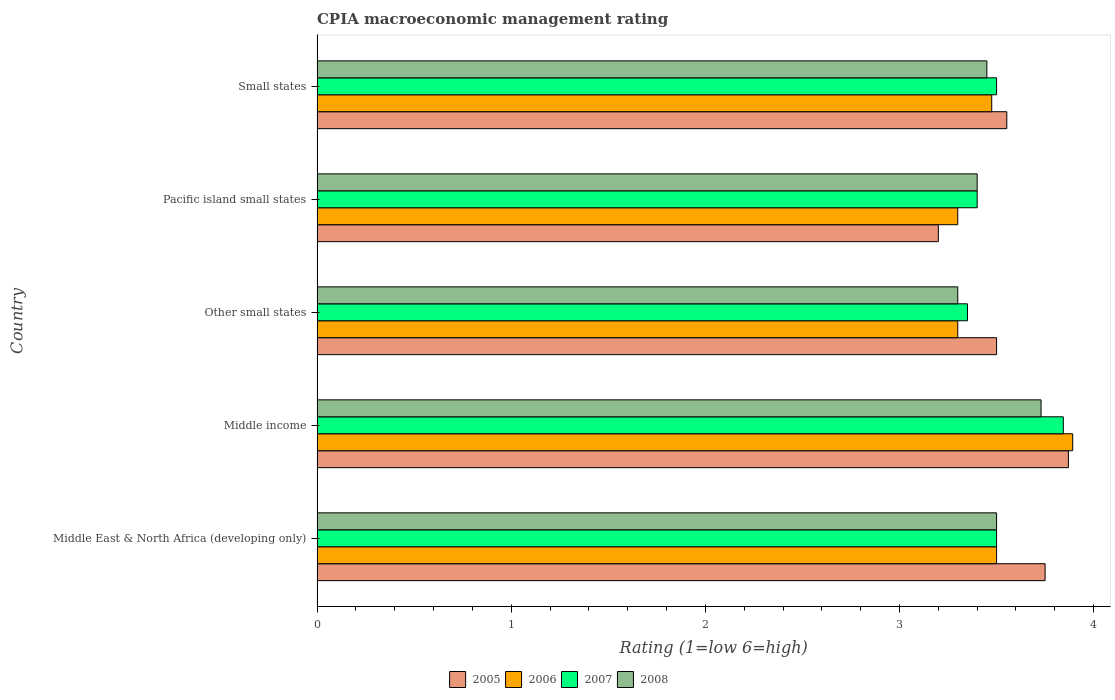How many different coloured bars are there?
Your response must be concise. 4. Are the number of bars on each tick of the Y-axis equal?
Your response must be concise. Yes. How many bars are there on the 5th tick from the top?
Your answer should be very brief. 4. How many bars are there on the 4th tick from the bottom?
Offer a terse response. 4. What is the label of the 5th group of bars from the top?
Provide a succinct answer. Middle East & North Africa (developing only). In how many cases, is the number of bars for a given country not equal to the number of legend labels?
Offer a very short reply. 0. Across all countries, what is the maximum CPIA rating in 2006?
Give a very brief answer. 3.89. In which country was the CPIA rating in 2006 minimum?
Ensure brevity in your answer.  Other small states. What is the total CPIA rating in 2007 in the graph?
Provide a short and direct response. 17.59. What is the difference between the CPIA rating in 2008 in Pacific island small states and that in Small states?
Make the answer very short. -0.05. What is the difference between the CPIA rating in 2006 in Pacific island small states and the CPIA rating in 2008 in Small states?
Your response must be concise. -0.15. What is the average CPIA rating in 2007 per country?
Provide a short and direct response. 3.52. What is the difference between the CPIA rating in 2008 and CPIA rating in 2005 in Middle income?
Give a very brief answer. -0.14. In how many countries, is the CPIA rating in 2005 greater than 0.2 ?
Offer a very short reply. 5. What is the ratio of the CPIA rating in 2007 in Other small states to that in Pacific island small states?
Your answer should be compact. 0.99. What is the difference between the highest and the second highest CPIA rating in 2006?
Offer a very short reply. 0.39. What is the difference between the highest and the lowest CPIA rating in 2008?
Your answer should be compact. 0.43. Is the sum of the CPIA rating in 2007 in Middle East & North Africa (developing only) and Pacific island small states greater than the maximum CPIA rating in 2006 across all countries?
Make the answer very short. Yes. How many bars are there?
Your response must be concise. 20. Are all the bars in the graph horizontal?
Keep it short and to the point. Yes. Are the values on the major ticks of X-axis written in scientific E-notation?
Your response must be concise. No. Does the graph contain any zero values?
Ensure brevity in your answer.  No. How many legend labels are there?
Your answer should be very brief. 4. How are the legend labels stacked?
Ensure brevity in your answer.  Horizontal. What is the title of the graph?
Offer a terse response. CPIA macroeconomic management rating. What is the label or title of the X-axis?
Your answer should be compact. Rating (1=low 6=high). What is the label or title of the Y-axis?
Give a very brief answer. Country. What is the Rating (1=low 6=high) in 2005 in Middle East & North Africa (developing only)?
Your response must be concise. 3.75. What is the Rating (1=low 6=high) in 2006 in Middle East & North Africa (developing only)?
Make the answer very short. 3.5. What is the Rating (1=low 6=high) of 2007 in Middle East & North Africa (developing only)?
Your answer should be compact. 3.5. What is the Rating (1=low 6=high) of 2005 in Middle income?
Ensure brevity in your answer.  3.87. What is the Rating (1=low 6=high) of 2006 in Middle income?
Your answer should be compact. 3.89. What is the Rating (1=low 6=high) in 2007 in Middle income?
Offer a terse response. 3.84. What is the Rating (1=low 6=high) in 2008 in Middle income?
Make the answer very short. 3.73. What is the Rating (1=low 6=high) of 2007 in Other small states?
Ensure brevity in your answer.  3.35. What is the Rating (1=low 6=high) of 2008 in Other small states?
Your answer should be very brief. 3.3. What is the Rating (1=low 6=high) of 2005 in Pacific island small states?
Offer a very short reply. 3.2. What is the Rating (1=low 6=high) of 2006 in Pacific island small states?
Make the answer very short. 3.3. What is the Rating (1=low 6=high) of 2007 in Pacific island small states?
Keep it short and to the point. 3.4. What is the Rating (1=low 6=high) of 2008 in Pacific island small states?
Your answer should be very brief. 3.4. What is the Rating (1=low 6=high) in 2005 in Small states?
Make the answer very short. 3.55. What is the Rating (1=low 6=high) of 2006 in Small states?
Offer a very short reply. 3.48. What is the Rating (1=low 6=high) of 2007 in Small states?
Provide a succinct answer. 3.5. What is the Rating (1=low 6=high) in 2008 in Small states?
Keep it short and to the point. 3.45. Across all countries, what is the maximum Rating (1=low 6=high) of 2005?
Provide a short and direct response. 3.87. Across all countries, what is the maximum Rating (1=low 6=high) in 2006?
Ensure brevity in your answer.  3.89. Across all countries, what is the maximum Rating (1=low 6=high) of 2007?
Ensure brevity in your answer.  3.84. Across all countries, what is the maximum Rating (1=low 6=high) in 2008?
Offer a terse response. 3.73. Across all countries, what is the minimum Rating (1=low 6=high) in 2006?
Your answer should be compact. 3.3. Across all countries, what is the minimum Rating (1=low 6=high) in 2007?
Offer a very short reply. 3.35. What is the total Rating (1=low 6=high) in 2005 in the graph?
Ensure brevity in your answer.  17.87. What is the total Rating (1=low 6=high) in 2006 in the graph?
Provide a succinct answer. 17.47. What is the total Rating (1=low 6=high) in 2007 in the graph?
Provide a short and direct response. 17.59. What is the total Rating (1=low 6=high) of 2008 in the graph?
Give a very brief answer. 17.38. What is the difference between the Rating (1=low 6=high) of 2005 in Middle East & North Africa (developing only) and that in Middle income?
Your response must be concise. -0.12. What is the difference between the Rating (1=low 6=high) in 2006 in Middle East & North Africa (developing only) and that in Middle income?
Ensure brevity in your answer.  -0.39. What is the difference between the Rating (1=low 6=high) in 2007 in Middle East & North Africa (developing only) and that in Middle income?
Give a very brief answer. -0.34. What is the difference between the Rating (1=low 6=high) of 2008 in Middle East & North Africa (developing only) and that in Middle income?
Make the answer very short. -0.23. What is the difference between the Rating (1=low 6=high) of 2005 in Middle East & North Africa (developing only) and that in Other small states?
Your answer should be very brief. 0.25. What is the difference between the Rating (1=low 6=high) of 2006 in Middle East & North Africa (developing only) and that in Other small states?
Offer a very short reply. 0.2. What is the difference between the Rating (1=low 6=high) of 2007 in Middle East & North Africa (developing only) and that in Other small states?
Your response must be concise. 0.15. What is the difference between the Rating (1=low 6=high) of 2008 in Middle East & North Africa (developing only) and that in Other small states?
Your response must be concise. 0.2. What is the difference between the Rating (1=low 6=high) in 2005 in Middle East & North Africa (developing only) and that in Pacific island small states?
Offer a very short reply. 0.55. What is the difference between the Rating (1=low 6=high) of 2006 in Middle East & North Africa (developing only) and that in Pacific island small states?
Make the answer very short. 0.2. What is the difference between the Rating (1=low 6=high) in 2005 in Middle East & North Africa (developing only) and that in Small states?
Offer a terse response. 0.2. What is the difference between the Rating (1=low 6=high) of 2006 in Middle East & North Africa (developing only) and that in Small states?
Your answer should be very brief. 0.03. What is the difference between the Rating (1=low 6=high) in 2007 in Middle East & North Africa (developing only) and that in Small states?
Ensure brevity in your answer.  0. What is the difference between the Rating (1=low 6=high) in 2008 in Middle East & North Africa (developing only) and that in Small states?
Offer a very short reply. 0.05. What is the difference between the Rating (1=low 6=high) in 2005 in Middle income and that in Other small states?
Make the answer very short. 0.37. What is the difference between the Rating (1=low 6=high) of 2006 in Middle income and that in Other small states?
Keep it short and to the point. 0.59. What is the difference between the Rating (1=low 6=high) in 2007 in Middle income and that in Other small states?
Make the answer very short. 0.49. What is the difference between the Rating (1=low 6=high) of 2008 in Middle income and that in Other small states?
Ensure brevity in your answer.  0.43. What is the difference between the Rating (1=low 6=high) of 2005 in Middle income and that in Pacific island small states?
Your answer should be compact. 0.67. What is the difference between the Rating (1=low 6=high) in 2006 in Middle income and that in Pacific island small states?
Your answer should be compact. 0.59. What is the difference between the Rating (1=low 6=high) in 2007 in Middle income and that in Pacific island small states?
Your answer should be compact. 0.44. What is the difference between the Rating (1=low 6=high) of 2008 in Middle income and that in Pacific island small states?
Provide a succinct answer. 0.33. What is the difference between the Rating (1=low 6=high) of 2005 in Middle income and that in Small states?
Your answer should be very brief. 0.32. What is the difference between the Rating (1=low 6=high) of 2006 in Middle income and that in Small states?
Provide a succinct answer. 0.42. What is the difference between the Rating (1=low 6=high) in 2007 in Middle income and that in Small states?
Your answer should be compact. 0.34. What is the difference between the Rating (1=low 6=high) in 2008 in Middle income and that in Small states?
Keep it short and to the point. 0.28. What is the difference between the Rating (1=low 6=high) in 2005 in Other small states and that in Pacific island small states?
Keep it short and to the point. 0.3. What is the difference between the Rating (1=low 6=high) of 2006 in Other small states and that in Pacific island small states?
Ensure brevity in your answer.  0. What is the difference between the Rating (1=low 6=high) of 2008 in Other small states and that in Pacific island small states?
Ensure brevity in your answer.  -0.1. What is the difference between the Rating (1=low 6=high) of 2005 in Other small states and that in Small states?
Your answer should be very brief. -0.05. What is the difference between the Rating (1=low 6=high) in 2006 in Other small states and that in Small states?
Give a very brief answer. -0.17. What is the difference between the Rating (1=low 6=high) in 2007 in Other small states and that in Small states?
Ensure brevity in your answer.  -0.15. What is the difference between the Rating (1=low 6=high) in 2005 in Pacific island small states and that in Small states?
Offer a very short reply. -0.35. What is the difference between the Rating (1=low 6=high) in 2006 in Pacific island small states and that in Small states?
Your response must be concise. -0.17. What is the difference between the Rating (1=low 6=high) in 2008 in Pacific island small states and that in Small states?
Keep it short and to the point. -0.05. What is the difference between the Rating (1=low 6=high) in 2005 in Middle East & North Africa (developing only) and the Rating (1=low 6=high) in 2006 in Middle income?
Your answer should be very brief. -0.14. What is the difference between the Rating (1=low 6=high) of 2005 in Middle East & North Africa (developing only) and the Rating (1=low 6=high) of 2007 in Middle income?
Your answer should be compact. -0.09. What is the difference between the Rating (1=low 6=high) of 2005 in Middle East & North Africa (developing only) and the Rating (1=low 6=high) of 2008 in Middle income?
Your response must be concise. 0.02. What is the difference between the Rating (1=low 6=high) in 2006 in Middle East & North Africa (developing only) and the Rating (1=low 6=high) in 2007 in Middle income?
Keep it short and to the point. -0.34. What is the difference between the Rating (1=low 6=high) in 2006 in Middle East & North Africa (developing only) and the Rating (1=low 6=high) in 2008 in Middle income?
Provide a short and direct response. -0.23. What is the difference between the Rating (1=low 6=high) in 2007 in Middle East & North Africa (developing only) and the Rating (1=low 6=high) in 2008 in Middle income?
Provide a short and direct response. -0.23. What is the difference between the Rating (1=low 6=high) of 2005 in Middle East & North Africa (developing only) and the Rating (1=low 6=high) of 2006 in Other small states?
Offer a terse response. 0.45. What is the difference between the Rating (1=low 6=high) in 2005 in Middle East & North Africa (developing only) and the Rating (1=low 6=high) in 2007 in Other small states?
Make the answer very short. 0.4. What is the difference between the Rating (1=low 6=high) in 2005 in Middle East & North Africa (developing only) and the Rating (1=low 6=high) in 2008 in Other small states?
Your answer should be compact. 0.45. What is the difference between the Rating (1=low 6=high) of 2006 in Middle East & North Africa (developing only) and the Rating (1=low 6=high) of 2007 in Other small states?
Ensure brevity in your answer.  0.15. What is the difference between the Rating (1=low 6=high) of 2006 in Middle East & North Africa (developing only) and the Rating (1=low 6=high) of 2008 in Other small states?
Keep it short and to the point. 0.2. What is the difference between the Rating (1=low 6=high) of 2005 in Middle East & North Africa (developing only) and the Rating (1=low 6=high) of 2006 in Pacific island small states?
Make the answer very short. 0.45. What is the difference between the Rating (1=low 6=high) in 2005 in Middle East & North Africa (developing only) and the Rating (1=low 6=high) in 2007 in Pacific island small states?
Offer a very short reply. 0.35. What is the difference between the Rating (1=low 6=high) in 2005 in Middle East & North Africa (developing only) and the Rating (1=low 6=high) in 2006 in Small states?
Ensure brevity in your answer.  0.28. What is the difference between the Rating (1=low 6=high) of 2005 in Middle East & North Africa (developing only) and the Rating (1=low 6=high) of 2008 in Small states?
Your answer should be very brief. 0.3. What is the difference between the Rating (1=low 6=high) of 2006 in Middle East & North Africa (developing only) and the Rating (1=low 6=high) of 2007 in Small states?
Your response must be concise. 0. What is the difference between the Rating (1=low 6=high) of 2007 in Middle East & North Africa (developing only) and the Rating (1=low 6=high) of 2008 in Small states?
Offer a very short reply. 0.05. What is the difference between the Rating (1=low 6=high) in 2005 in Middle income and the Rating (1=low 6=high) in 2006 in Other small states?
Offer a terse response. 0.57. What is the difference between the Rating (1=low 6=high) of 2005 in Middle income and the Rating (1=low 6=high) of 2007 in Other small states?
Make the answer very short. 0.52. What is the difference between the Rating (1=low 6=high) in 2005 in Middle income and the Rating (1=low 6=high) in 2008 in Other small states?
Provide a succinct answer. 0.57. What is the difference between the Rating (1=low 6=high) in 2006 in Middle income and the Rating (1=low 6=high) in 2007 in Other small states?
Provide a succinct answer. 0.54. What is the difference between the Rating (1=low 6=high) in 2006 in Middle income and the Rating (1=low 6=high) in 2008 in Other small states?
Your answer should be compact. 0.59. What is the difference between the Rating (1=low 6=high) of 2007 in Middle income and the Rating (1=low 6=high) of 2008 in Other small states?
Keep it short and to the point. 0.54. What is the difference between the Rating (1=low 6=high) in 2005 in Middle income and the Rating (1=low 6=high) in 2006 in Pacific island small states?
Offer a very short reply. 0.57. What is the difference between the Rating (1=low 6=high) of 2005 in Middle income and the Rating (1=low 6=high) of 2007 in Pacific island small states?
Your answer should be very brief. 0.47. What is the difference between the Rating (1=low 6=high) of 2005 in Middle income and the Rating (1=low 6=high) of 2008 in Pacific island small states?
Make the answer very short. 0.47. What is the difference between the Rating (1=low 6=high) in 2006 in Middle income and the Rating (1=low 6=high) in 2007 in Pacific island small states?
Make the answer very short. 0.49. What is the difference between the Rating (1=low 6=high) of 2006 in Middle income and the Rating (1=low 6=high) of 2008 in Pacific island small states?
Ensure brevity in your answer.  0.49. What is the difference between the Rating (1=low 6=high) in 2007 in Middle income and the Rating (1=low 6=high) in 2008 in Pacific island small states?
Provide a short and direct response. 0.44. What is the difference between the Rating (1=low 6=high) of 2005 in Middle income and the Rating (1=low 6=high) of 2006 in Small states?
Make the answer very short. 0.4. What is the difference between the Rating (1=low 6=high) of 2005 in Middle income and the Rating (1=low 6=high) of 2007 in Small states?
Your answer should be compact. 0.37. What is the difference between the Rating (1=low 6=high) of 2005 in Middle income and the Rating (1=low 6=high) of 2008 in Small states?
Your response must be concise. 0.42. What is the difference between the Rating (1=low 6=high) in 2006 in Middle income and the Rating (1=low 6=high) in 2007 in Small states?
Make the answer very short. 0.39. What is the difference between the Rating (1=low 6=high) of 2006 in Middle income and the Rating (1=low 6=high) of 2008 in Small states?
Ensure brevity in your answer.  0.44. What is the difference between the Rating (1=low 6=high) of 2007 in Middle income and the Rating (1=low 6=high) of 2008 in Small states?
Offer a very short reply. 0.39. What is the difference between the Rating (1=low 6=high) of 2005 in Other small states and the Rating (1=low 6=high) of 2008 in Pacific island small states?
Offer a very short reply. 0.1. What is the difference between the Rating (1=low 6=high) in 2006 in Other small states and the Rating (1=low 6=high) in 2007 in Pacific island small states?
Offer a terse response. -0.1. What is the difference between the Rating (1=low 6=high) of 2005 in Other small states and the Rating (1=low 6=high) of 2006 in Small states?
Your answer should be very brief. 0.03. What is the difference between the Rating (1=low 6=high) of 2006 in Other small states and the Rating (1=low 6=high) of 2007 in Small states?
Your answer should be very brief. -0.2. What is the difference between the Rating (1=low 6=high) of 2006 in Other small states and the Rating (1=low 6=high) of 2008 in Small states?
Ensure brevity in your answer.  -0.15. What is the difference between the Rating (1=low 6=high) of 2005 in Pacific island small states and the Rating (1=low 6=high) of 2006 in Small states?
Provide a succinct answer. -0.28. What is the difference between the Rating (1=low 6=high) in 2005 in Pacific island small states and the Rating (1=low 6=high) in 2007 in Small states?
Make the answer very short. -0.3. What is the average Rating (1=low 6=high) in 2005 per country?
Your answer should be compact. 3.57. What is the average Rating (1=low 6=high) in 2006 per country?
Make the answer very short. 3.49. What is the average Rating (1=low 6=high) of 2007 per country?
Your answer should be very brief. 3.52. What is the average Rating (1=low 6=high) of 2008 per country?
Your response must be concise. 3.48. What is the difference between the Rating (1=low 6=high) of 2006 and Rating (1=low 6=high) of 2008 in Middle East & North Africa (developing only)?
Offer a terse response. 0. What is the difference between the Rating (1=low 6=high) in 2005 and Rating (1=low 6=high) in 2006 in Middle income?
Your answer should be very brief. -0.02. What is the difference between the Rating (1=low 6=high) in 2005 and Rating (1=low 6=high) in 2007 in Middle income?
Give a very brief answer. 0.03. What is the difference between the Rating (1=low 6=high) of 2005 and Rating (1=low 6=high) of 2008 in Middle income?
Offer a terse response. 0.14. What is the difference between the Rating (1=low 6=high) of 2006 and Rating (1=low 6=high) of 2007 in Middle income?
Keep it short and to the point. 0.05. What is the difference between the Rating (1=low 6=high) in 2006 and Rating (1=low 6=high) in 2008 in Middle income?
Give a very brief answer. 0.16. What is the difference between the Rating (1=low 6=high) of 2007 and Rating (1=low 6=high) of 2008 in Middle income?
Provide a succinct answer. 0.11. What is the difference between the Rating (1=low 6=high) of 2005 and Rating (1=low 6=high) of 2006 in Other small states?
Your answer should be very brief. 0.2. What is the difference between the Rating (1=low 6=high) in 2007 and Rating (1=low 6=high) in 2008 in Other small states?
Your answer should be very brief. 0.05. What is the difference between the Rating (1=low 6=high) in 2005 and Rating (1=low 6=high) in 2006 in Pacific island small states?
Provide a short and direct response. -0.1. What is the difference between the Rating (1=low 6=high) in 2005 and Rating (1=low 6=high) in 2007 in Pacific island small states?
Provide a succinct answer. -0.2. What is the difference between the Rating (1=low 6=high) in 2006 and Rating (1=low 6=high) in 2007 in Pacific island small states?
Make the answer very short. -0.1. What is the difference between the Rating (1=low 6=high) in 2006 and Rating (1=low 6=high) in 2008 in Pacific island small states?
Offer a terse response. -0.1. What is the difference between the Rating (1=low 6=high) in 2007 and Rating (1=low 6=high) in 2008 in Pacific island small states?
Offer a very short reply. 0. What is the difference between the Rating (1=low 6=high) of 2005 and Rating (1=low 6=high) of 2006 in Small states?
Provide a short and direct response. 0.08. What is the difference between the Rating (1=low 6=high) of 2005 and Rating (1=low 6=high) of 2007 in Small states?
Keep it short and to the point. 0.05. What is the difference between the Rating (1=low 6=high) of 2005 and Rating (1=low 6=high) of 2008 in Small states?
Your answer should be compact. 0.1. What is the difference between the Rating (1=low 6=high) in 2006 and Rating (1=low 6=high) in 2007 in Small states?
Ensure brevity in your answer.  -0.03. What is the difference between the Rating (1=low 6=high) of 2006 and Rating (1=low 6=high) of 2008 in Small states?
Provide a short and direct response. 0.03. What is the ratio of the Rating (1=low 6=high) of 2006 in Middle East & North Africa (developing only) to that in Middle income?
Make the answer very short. 0.9. What is the ratio of the Rating (1=low 6=high) in 2007 in Middle East & North Africa (developing only) to that in Middle income?
Your response must be concise. 0.91. What is the ratio of the Rating (1=low 6=high) in 2008 in Middle East & North Africa (developing only) to that in Middle income?
Your response must be concise. 0.94. What is the ratio of the Rating (1=low 6=high) of 2005 in Middle East & North Africa (developing only) to that in Other small states?
Offer a very short reply. 1.07. What is the ratio of the Rating (1=low 6=high) in 2006 in Middle East & North Africa (developing only) to that in Other small states?
Your answer should be very brief. 1.06. What is the ratio of the Rating (1=low 6=high) in 2007 in Middle East & North Africa (developing only) to that in Other small states?
Your response must be concise. 1.04. What is the ratio of the Rating (1=low 6=high) of 2008 in Middle East & North Africa (developing only) to that in Other small states?
Your answer should be very brief. 1.06. What is the ratio of the Rating (1=low 6=high) in 2005 in Middle East & North Africa (developing only) to that in Pacific island small states?
Your answer should be compact. 1.17. What is the ratio of the Rating (1=low 6=high) of 2006 in Middle East & North Africa (developing only) to that in Pacific island small states?
Provide a succinct answer. 1.06. What is the ratio of the Rating (1=low 6=high) of 2007 in Middle East & North Africa (developing only) to that in Pacific island small states?
Keep it short and to the point. 1.03. What is the ratio of the Rating (1=low 6=high) in 2008 in Middle East & North Africa (developing only) to that in Pacific island small states?
Provide a succinct answer. 1.03. What is the ratio of the Rating (1=low 6=high) in 2005 in Middle East & North Africa (developing only) to that in Small states?
Your response must be concise. 1.06. What is the ratio of the Rating (1=low 6=high) of 2006 in Middle East & North Africa (developing only) to that in Small states?
Your answer should be compact. 1.01. What is the ratio of the Rating (1=low 6=high) in 2007 in Middle East & North Africa (developing only) to that in Small states?
Provide a short and direct response. 1. What is the ratio of the Rating (1=low 6=high) of 2008 in Middle East & North Africa (developing only) to that in Small states?
Your answer should be very brief. 1.01. What is the ratio of the Rating (1=low 6=high) in 2005 in Middle income to that in Other small states?
Your answer should be very brief. 1.11. What is the ratio of the Rating (1=low 6=high) in 2006 in Middle income to that in Other small states?
Provide a succinct answer. 1.18. What is the ratio of the Rating (1=low 6=high) in 2007 in Middle income to that in Other small states?
Offer a very short reply. 1.15. What is the ratio of the Rating (1=low 6=high) in 2008 in Middle income to that in Other small states?
Offer a terse response. 1.13. What is the ratio of the Rating (1=low 6=high) in 2005 in Middle income to that in Pacific island small states?
Give a very brief answer. 1.21. What is the ratio of the Rating (1=low 6=high) of 2006 in Middle income to that in Pacific island small states?
Offer a very short reply. 1.18. What is the ratio of the Rating (1=low 6=high) in 2007 in Middle income to that in Pacific island small states?
Your answer should be very brief. 1.13. What is the ratio of the Rating (1=low 6=high) of 2008 in Middle income to that in Pacific island small states?
Your answer should be very brief. 1.1. What is the ratio of the Rating (1=low 6=high) in 2005 in Middle income to that in Small states?
Your answer should be very brief. 1.09. What is the ratio of the Rating (1=low 6=high) of 2006 in Middle income to that in Small states?
Provide a short and direct response. 1.12. What is the ratio of the Rating (1=low 6=high) of 2007 in Middle income to that in Small states?
Keep it short and to the point. 1.1. What is the ratio of the Rating (1=low 6=high) of 2008 in Middle income to that in Small states?
Keep it short and to the point. 1.08. What is the ratio of the Rating (1=low 6=high) in 2005 in Other small states to that in Pacific island small states?
Keep it short and to the point. 1.09. What is the ratio of the Rating (1=low 6=high) of 2006 in Other small states to that in Pacific island small states?
Give a very brief answer. 1. What is the ratio of the Rating (1=low 6=high) of 2007 in Other small states to that in Pacific island small states?
Keep it short and to the point. 0.99. What is the ratio of the Rating (1=low 6=high) of 2008 in Other small states to that in Pacific island small states?
Make the answer very short. 0.97. What is the ratio of the Rating (1=low 6=high) of 2005 in Other small states to that in Small states?
Provide a short and direct response. 0.99. What is the ratio of the Rating (1=low 6=high) in 2006 in Other small states to that in Small states?
Your response must be concise. 0.95. What is the ratio of the Rating (1=low 6=high) in 2007 in Other small states to that in Small states?
Offer a very short reply. 0.96. What is the ratio of the Rating (1=low 6=high) of 2008 in Other small states to that in Small states?
Give a very brief answer. 0.96. What is the ratio of the Rating (1=low 6=high) of 2005 in Pacific island small states to that in Small states?
Offer a terse response. 0.9. What is the ratio of the Rating (1=low 6=high) of 2006 in Pacific island small states to that in Small states?
Keep it short and to the point. 0.95. What is the ratio of the Rating (1=low 6=high) in 2007 in Pacific island small states to that in Small states?
Give a very brief answer. 0.97. What is the ratio of the Rating (1=low 6=high) in 2008 in Pacific island small states to that in Small states?
Your response must be concise. 0.99. What is the difference between the highest and the second highest Rating (1=low 6=high) of 2005?
Provide a succinct answer. 0.12. What is the difference between the highest and the second highest Rating (1=low 6=high) in 2006?
Offer a very short reply. 0.39. What is the difference between the highest and the second highest Rating (1=low 6=high) of 2007?
Your answer should be very brief. 0.34. What is the difference between the highest and the second highest Rating (1=low 6=high) in 2008?
Ensure brevity in your answer.  0.23. What is the difference between the highest and the lowest Rating (1=low 6=high) in 2005?
Offer a terse response. 0.67. What is the difference between the highest and the lowest Rating (1=low 6=high) in 2006?
Your answer should be very brief. 0.59. What is the difference between the highest and the lowest Rating (1=low 6=high) of 2007?
Ensure brevity in your answer.  0.49. What is the difference between the highest and the lowest Rating (1=low 6=high) of 2008?
Your answer should be very brief. 0.43. 